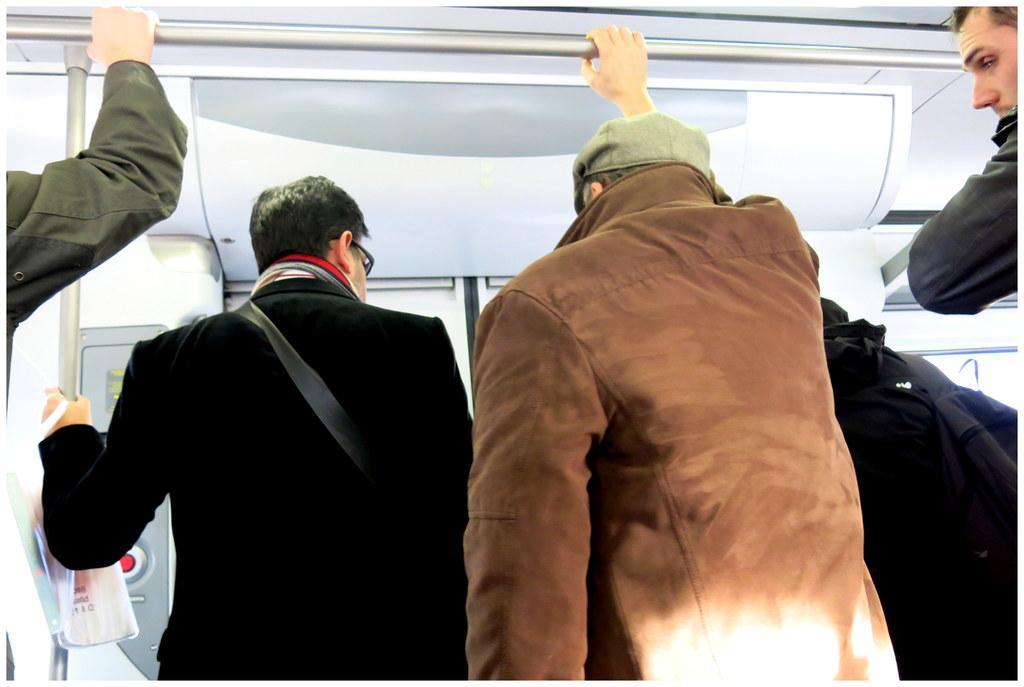Describe this image in one or two sentences. In this image, we can see few people. Here two persons are holding rods. Background we can see few things and door. On the left side top of the image, we can see a person hand is holding a rod. 